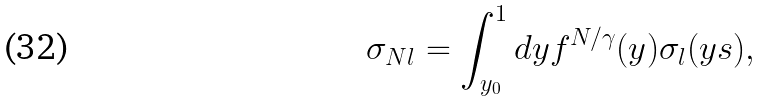Convert formula to latex. <formula><loc_0><loc_0><loc_500><loc_500>\sigma _ { N l } = \int _ { y _ { 0 } } ^ { 1 } d y f ^ { N / \gamma } ( y ) \sigma _ { l } ( y s ) ,</formula> 